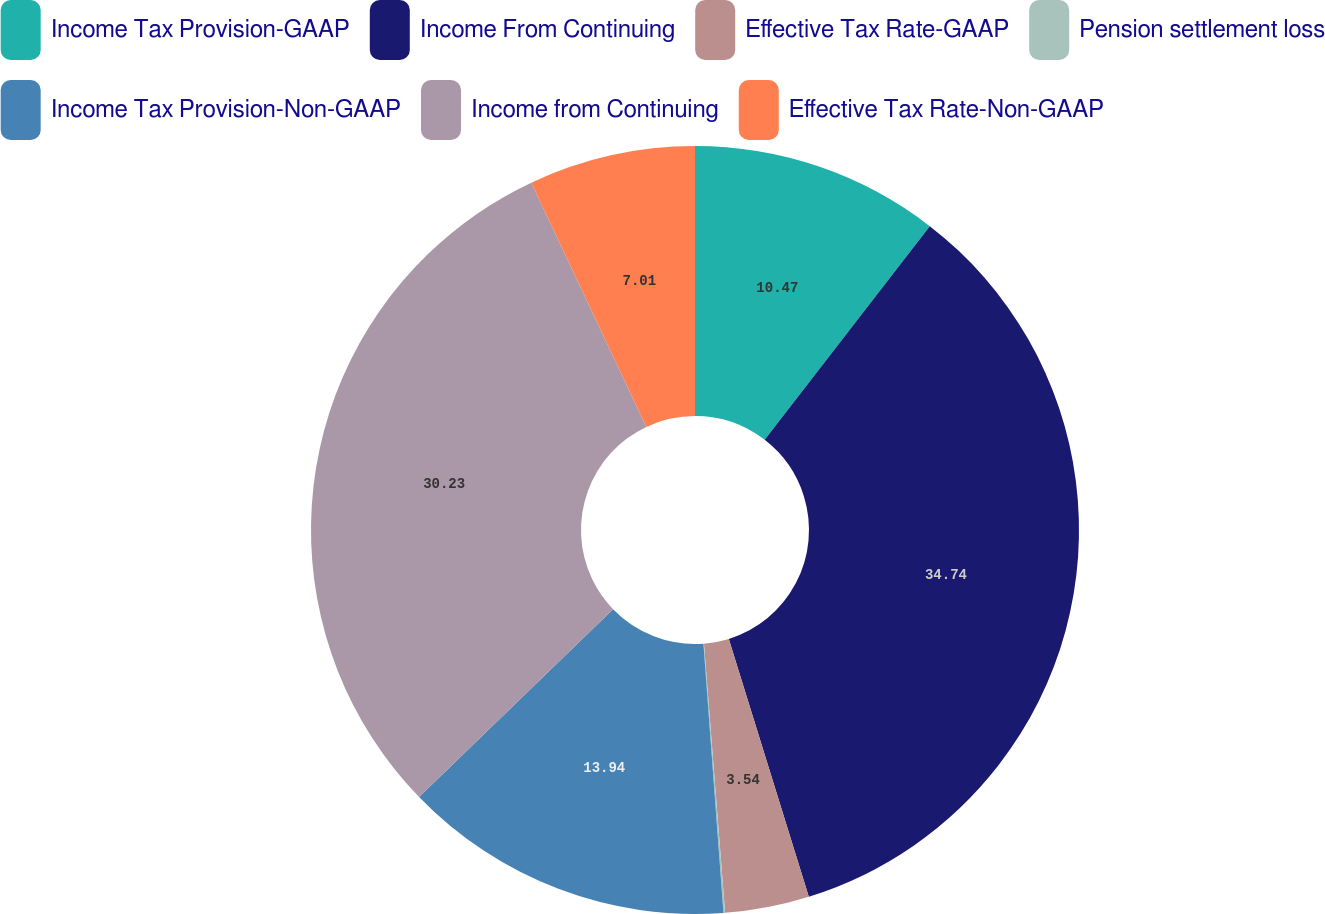<chart> <loc_0><loc_0><loc_500><loc_500><pie_chart><fcel>Income Tax Provision-GAAP<fcel>Income From Continuing<fcel>Effective Tax Rate-GAAP<fcel>Pension settlement loss<fcel>Income Tax Provision-Non-GAAP<fcel>Income from Continuing<fcel>Effective Tax Rate-Non-GAAP<nl><fcel>10.47%<fcel>34.74%<fcel>3.54%<fcel>0.07%<fcel>13.94%<fcel>30.23%<fcel>7.01%<nl></chart> 